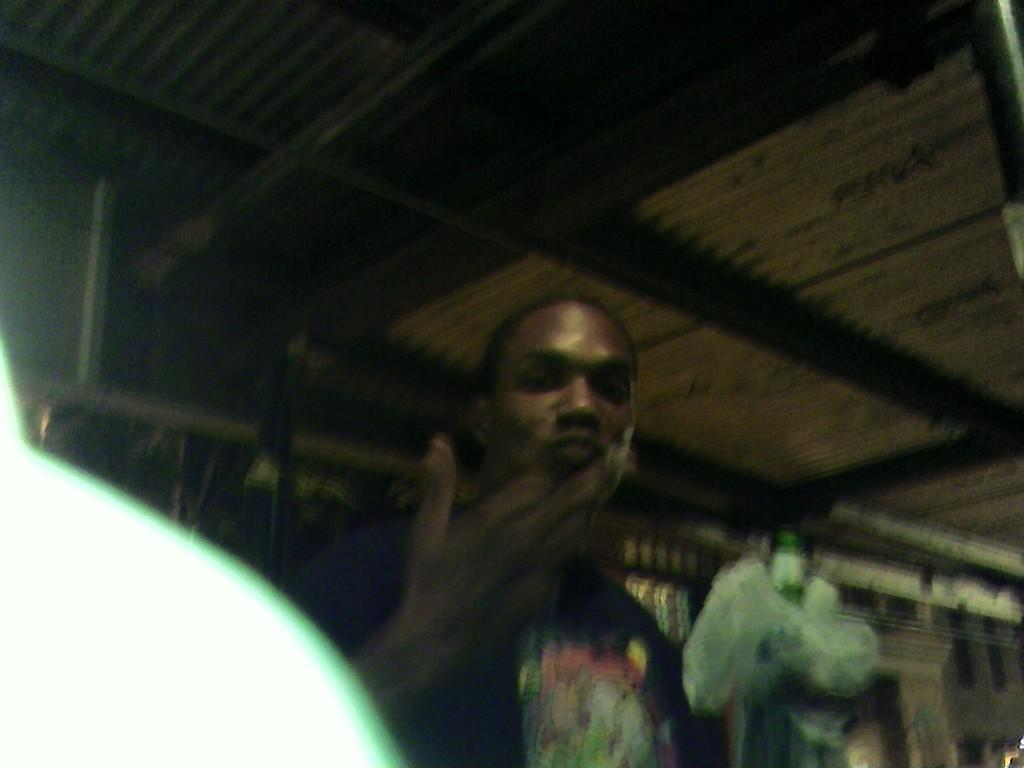Who is present in the image? There is a man in the image. What is the man holding in the image? The man is holding a bottle. What can be seen in the background of the image? There is a roof with iron sheets and other items visible in the background of the image. What type of arch can be seen in the man's stomach in the image? There is no arch visible in the man's stomach in the image. 